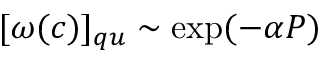<formula> <loc_0><loc_0><loc_500><loc_500>[ \omega ( c ) ] _ { q u } \sim \exp ( - \alpha P )</formula> 